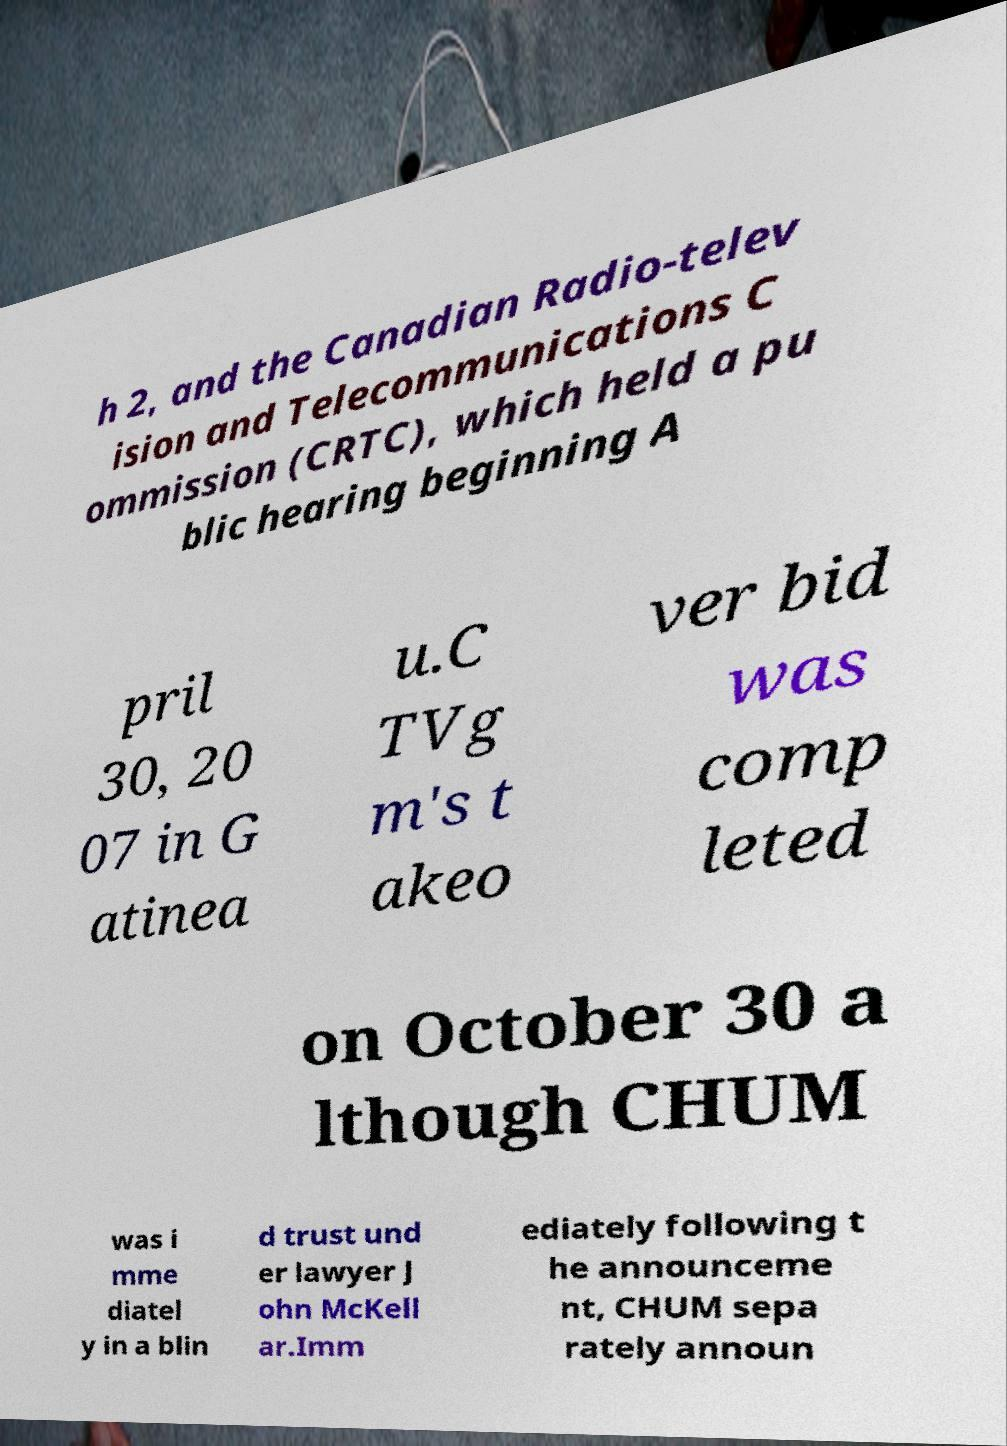Please read and relay the text visible in this image. What does it say? h 2, and the Canadian Radio-telev ision and Telecommunications C ommission (CRTC), which held a pu blic hearing beginning A pril 30, 20 07 in G atinea u.C TVg m's t akeo ver bid was comp leted on October 30 a lthough CHUM was i mme diatel y in a blin d trust und er lawyer J ohn McKell ar.Imm ediately following t he announceme nt, CHUM sepa rately announ 